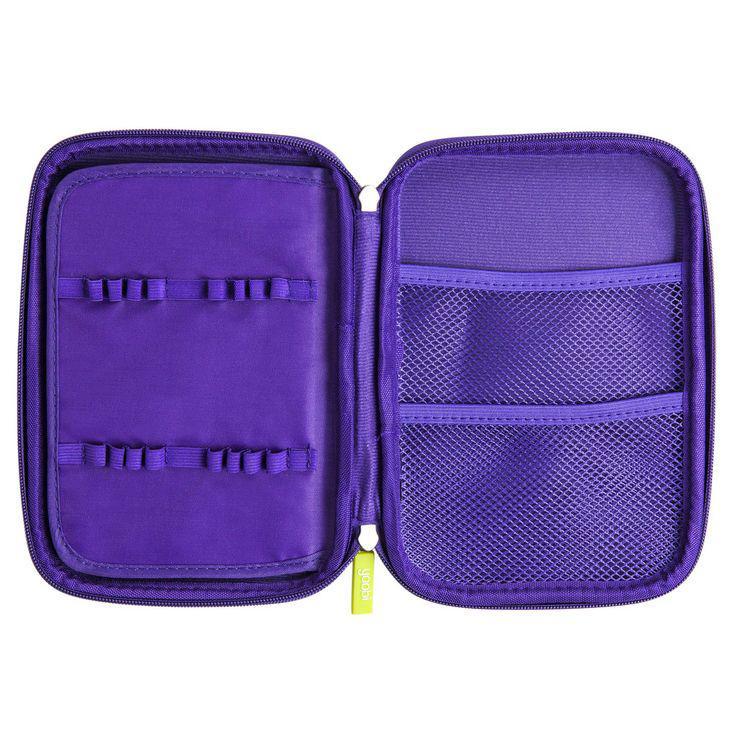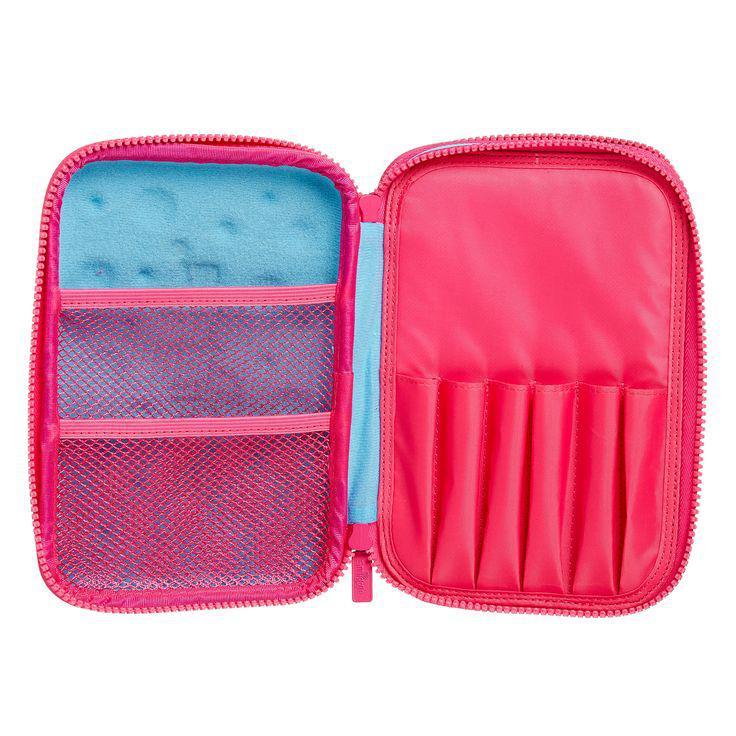The first image is the image on the left, the second image is the image on the right. For the images shown, is this caption "An image shows a closed, flat case with red and blue elements and multiple zippers across the front." true? Answer yes or no. No. The first image is the image on the left, the second image is the image on the right. Analyze the images presented: Is the assertion "There is a thick pencil case and a thin one, both closed." valid? Answer yes or no. No. 